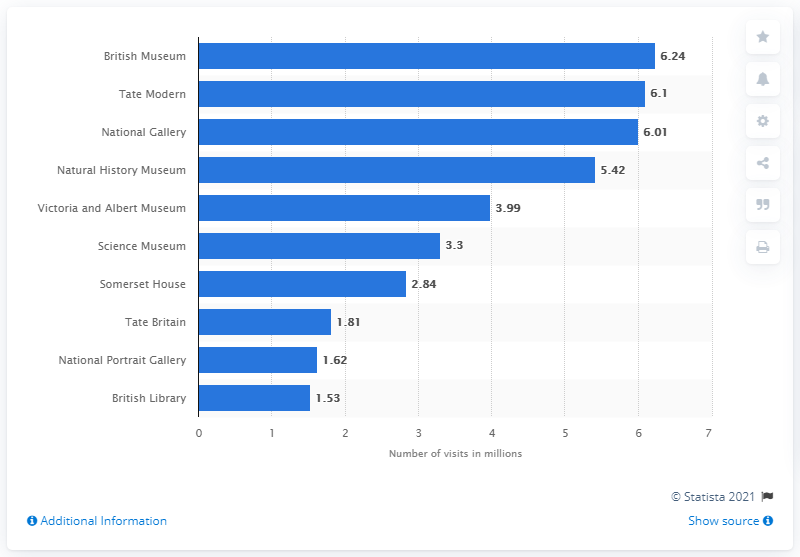Specify some key components in this picture. In 2019, the British Museum was visited by 6.24 people. 